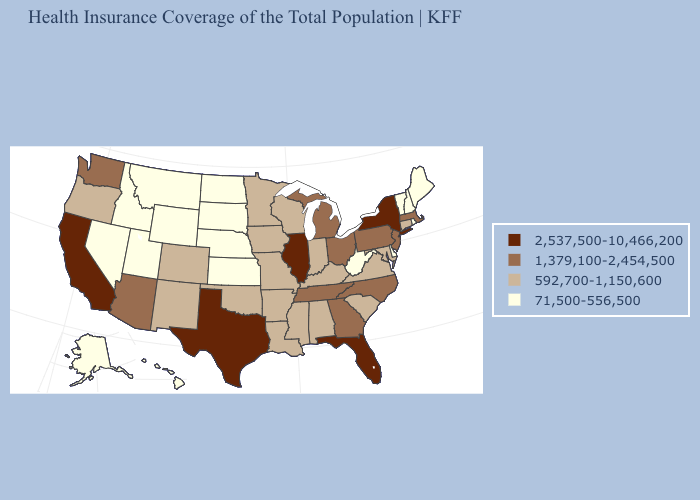Among the states that border Iowa , does Illinois have the highest value?
Give a very brief answer. Yes. What is the value of North Dakota?
Be succinct. 71,500-556,500. Does Wyoming have the lowest value in the West?
Short answer required. Yes. What is the lowest value in the USA?
Concise answer only. 71,500-556,500. Does North Dakota have the highest value in the MidWest?
Be succinct. No. Name the states that have a value in the range 71,500-556,500?
Concise answer only. Alaska, Delaware, Hawaii, Idaho, Kansas, Maine, Montana, Nebraska, Nevada, New Hampshire, North Dakota, Rhode Island, South Dakota, Utah, Vermont, West Virginia, Wyoming. Does the map have missing data?
Keep it brief. No. Name the states that have a value in the range 2,537,500-10,466,200?
Quick response, please. California, Florida, Illinois, New York, Texas. How many symbols are there in the legend?
Be succinct. 4. Name the states that have a value in the range 1,379,100-2,454,500?
Concise answer only. Arizona, Georgia, Massachusetts, Michigan, New Jersey, North Carolina, Ohio, Pennsylvania, Tennessee, Washington. Does Illinois have the highest value in the MidWest?
Keep it brief. Yes. Among the states that border Oregon , does California have the lowest value?
Give a very brief answer. No. Does Massachusetts have the lowest value in the Northeast?
Give a very brief answer. No. Among the states that border California , which have the highest value?
Give a very brief answer. Arizona. Name the states that have a value in the range 2,537,500-10,466,200?
Short answer required. California, Florida, Illinois, New York, Texas. 